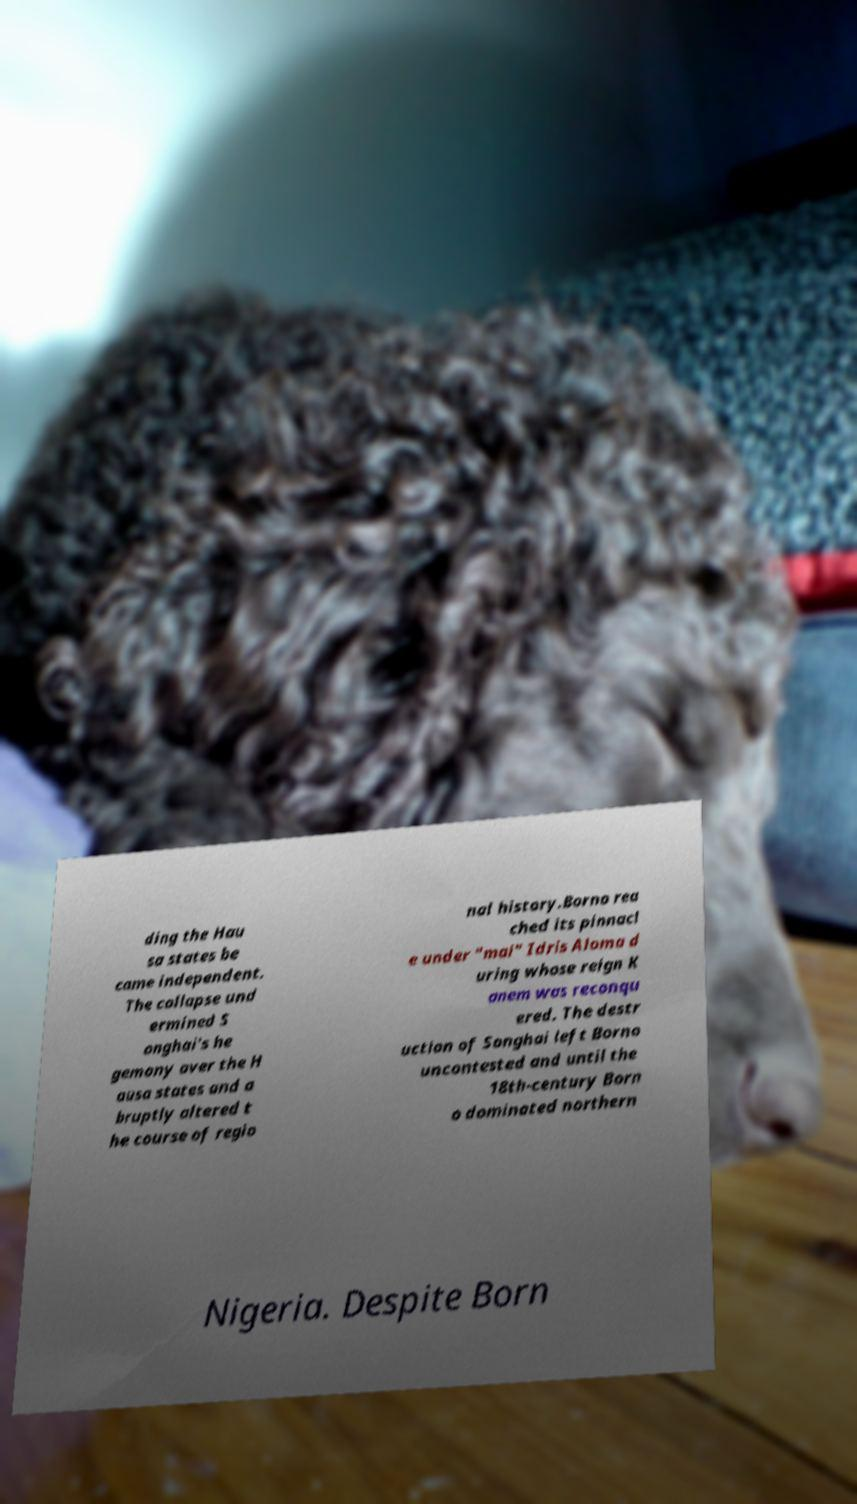There's text embedded in this image that I need extracted. Can you transcribe it verbatim? ding the Hau sa states be came independent. The collapse und ermined S onghai's he gemony over the H ausa states and a bruptly altered t he course of regio nal history.Borno rea ched its pinnacl e under "mai" Idris Aloma d uring whose reign K anem was reconqu ered. The destr uction of Songhai left Borno uncontested and until the 18th-century Born o dominated northern Nigeria. Despite Born 